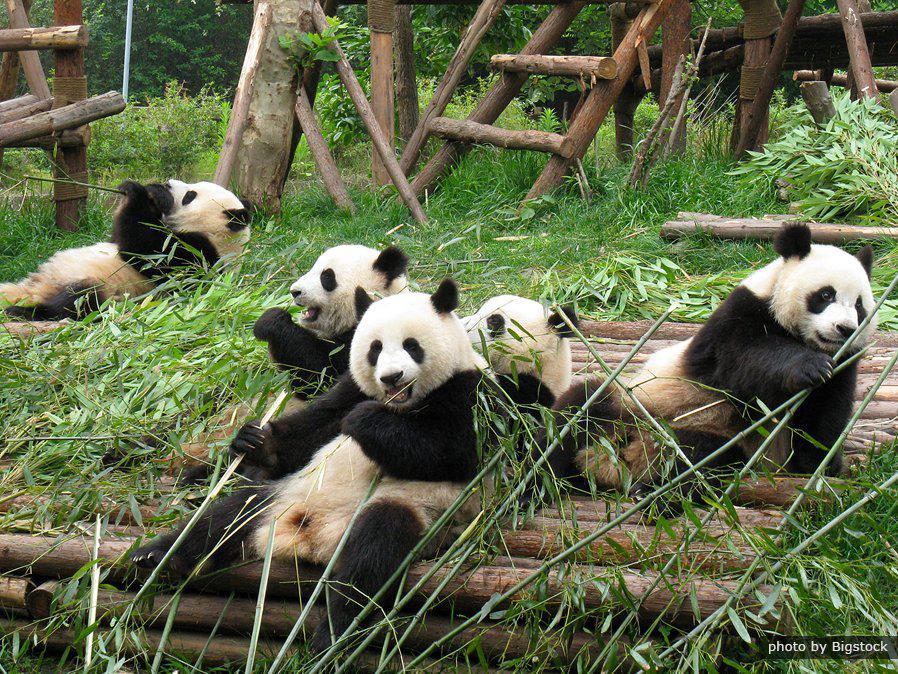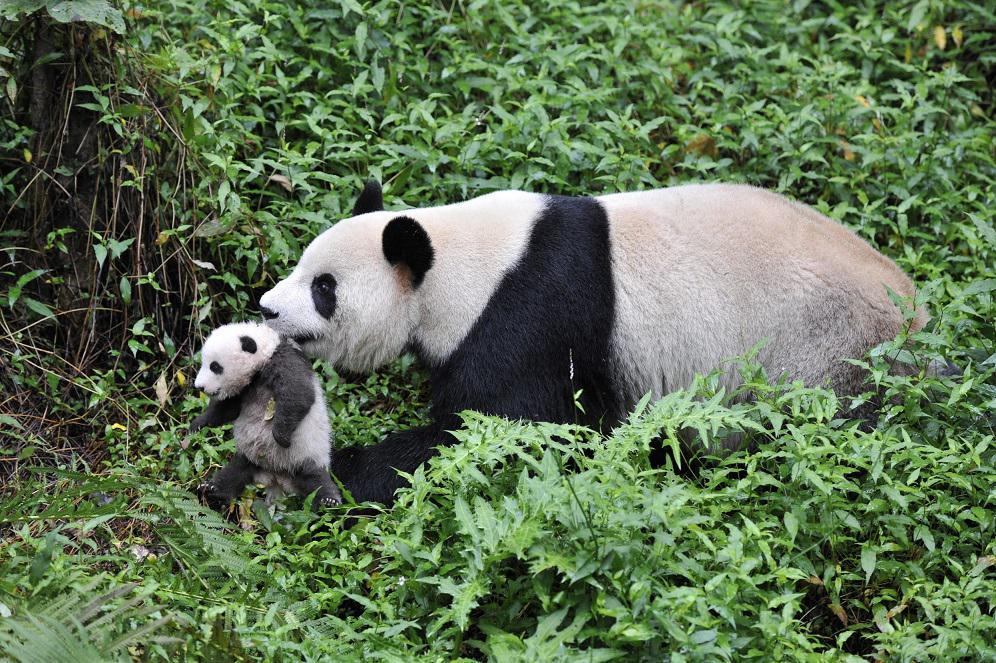The first image is the image on the left, the second image is the image on the right. Given the left and right images, does the statement "The left image contains exactly one panda." hold true? Answer yes or no. No. The first image is the image on the left, the second image is the image on the right. Analyze the images presented: Is the assertion "A panda is climbing a wooden limb in one image, and pandas are munching on bamboo leaves in the other image." valid? Answer yes or no. No. 